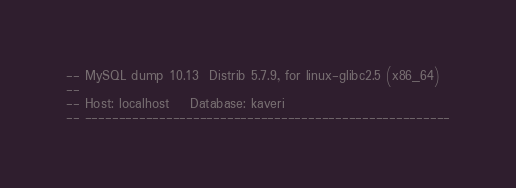<code> <loc_0><loc_0><loc_500><loc_500><_SQL_>-- MySQL dump 10.13  Distrib 5.7.9, for linux-glibc2.5 (x86_64)
--
-- Host: localhost    Database: kaveri
-- ------------------------------------------------------</code> 